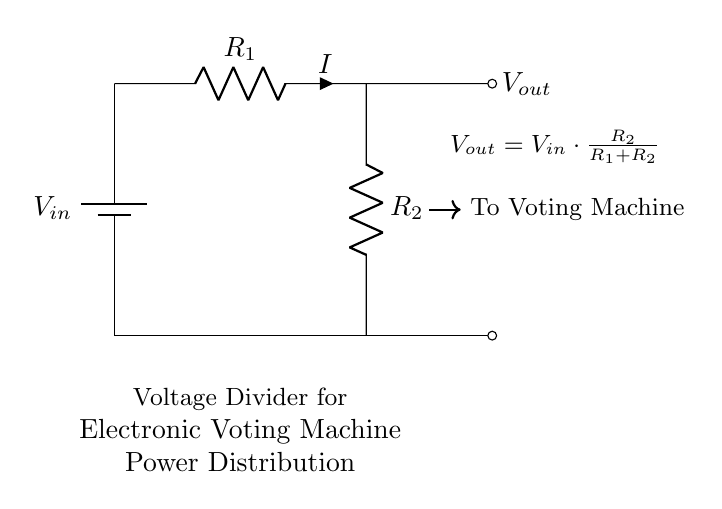What is the input voltage in this circuit? The input voltage is denoted as V_in, indicated by the battery symbol in the diagram. This represents the voltage supplied to the voltage divider circuit.
Answer: V_in What is the output voltage formula? The output voltage formula is provided in the circuit diagram as V_out = V_in * (R_2 / (R_1 + R_2)). This shows the relationship between the input and output voltages based on the resistance values.
Answer: V_out = V_in * (R_2 / (R_1 + R_2)) What components are used in this circuit? The main components are a battery, two resistors (R_1 and R_2), and connecting wires. The battery supplies power while the resistors divide the voltage for the voting machine.
Answer: Battery, R_1, R_2 What happens to V_out when R_2 is much larger than R_1? When R_2 is much larger than R_1, the output voltage V_out approaches V_in, as it suggests the majority of the voltage drops across R_2. This is due to the voltage division principle.
Answer: Approaches V_in What is the relationship between R_1 and R_2 for equal voltage division? For equal voltage division, R_1 should equal R_2. This is because V_out will be half of V_in when both resistors have the same resistance value, ensuring equal voltage distribution.
Answer: R_1 = R_2 What is the current flowing through R_1? The current I is equal to V_in divided by the total resistance (R_1 + R_2). This determines how much current flows through the series resistors in the circuit.
Answer: I = V_in / (R_1 + R_2) 